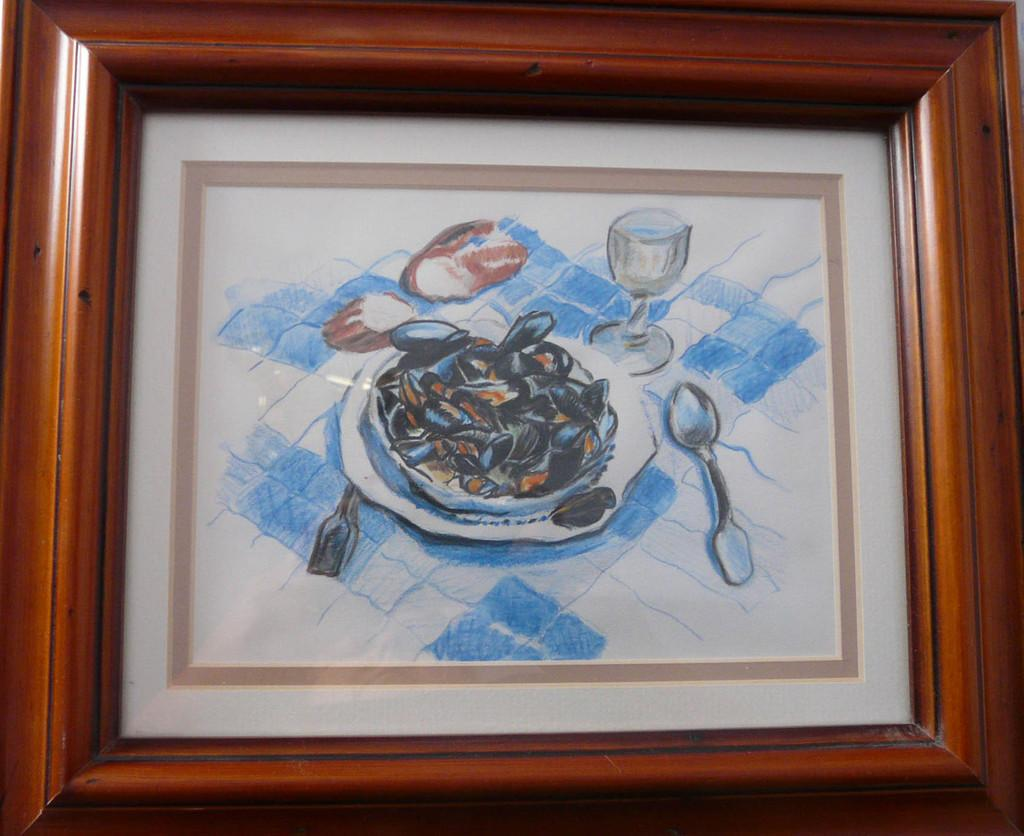What is the main object in the image? There is a frame in the image. What is inside the frame? The frame contains a picture. What is depicted in the picture? The picture depicts a wine glass, a spoon, and a plate. What is on the plate in the picture? The plate has food on it. How many geese are flying over the plate in the image? There are no geese present in the image; the picture only depicts a wine glass, a spoon, and a plate with food on it. What type of ink is used to draw the spoon in the image? The image is a photograph, not a drawing, so there is no ink used in the image. 